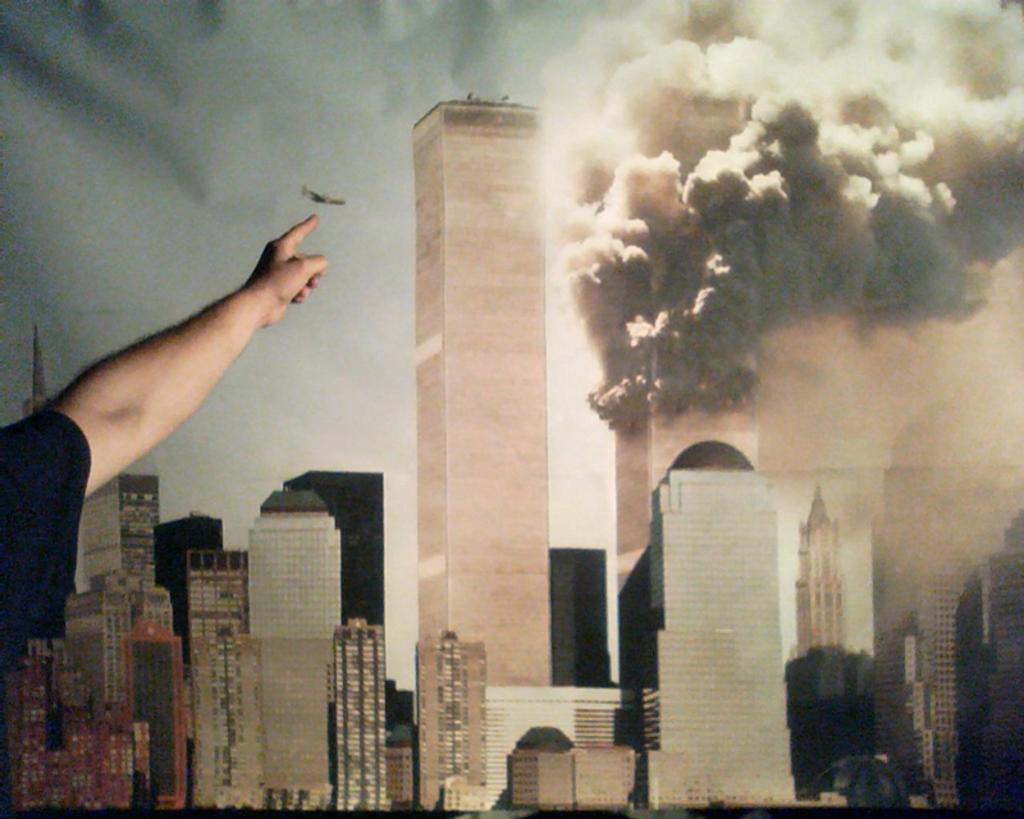Can you describe this image briefly? In this image we can see some person pointing to the painting and the painting consists of many buildings and we can also see the smoke releasing from the building. Sky is also visible in the painting. 